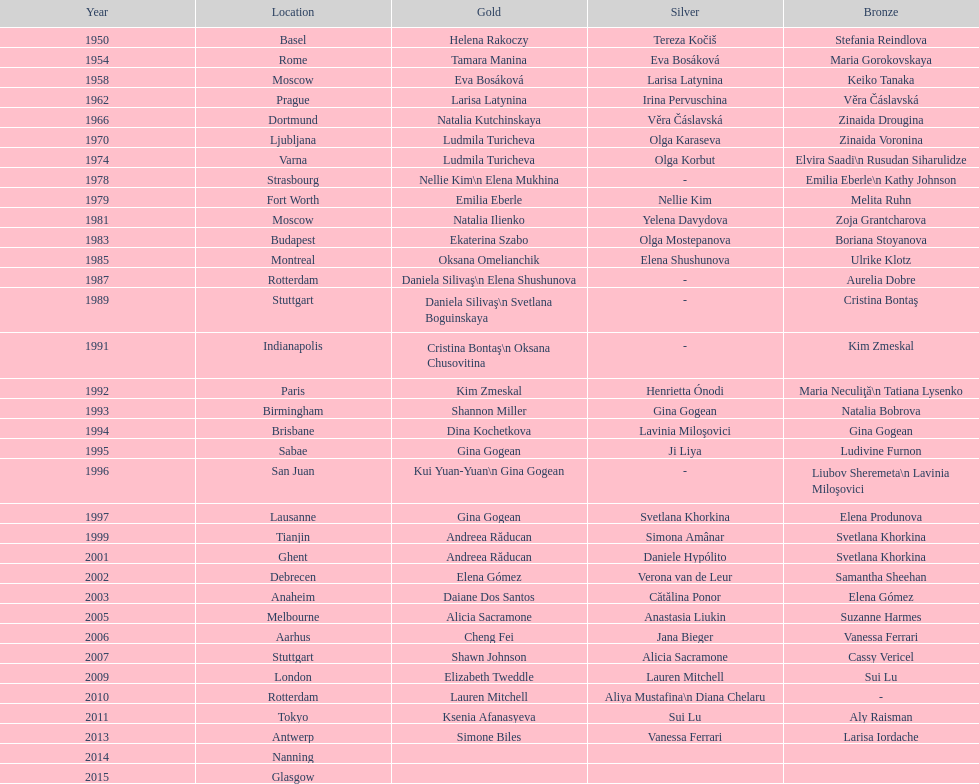How many russian gymnasts have secured silver medals in total? 8. 